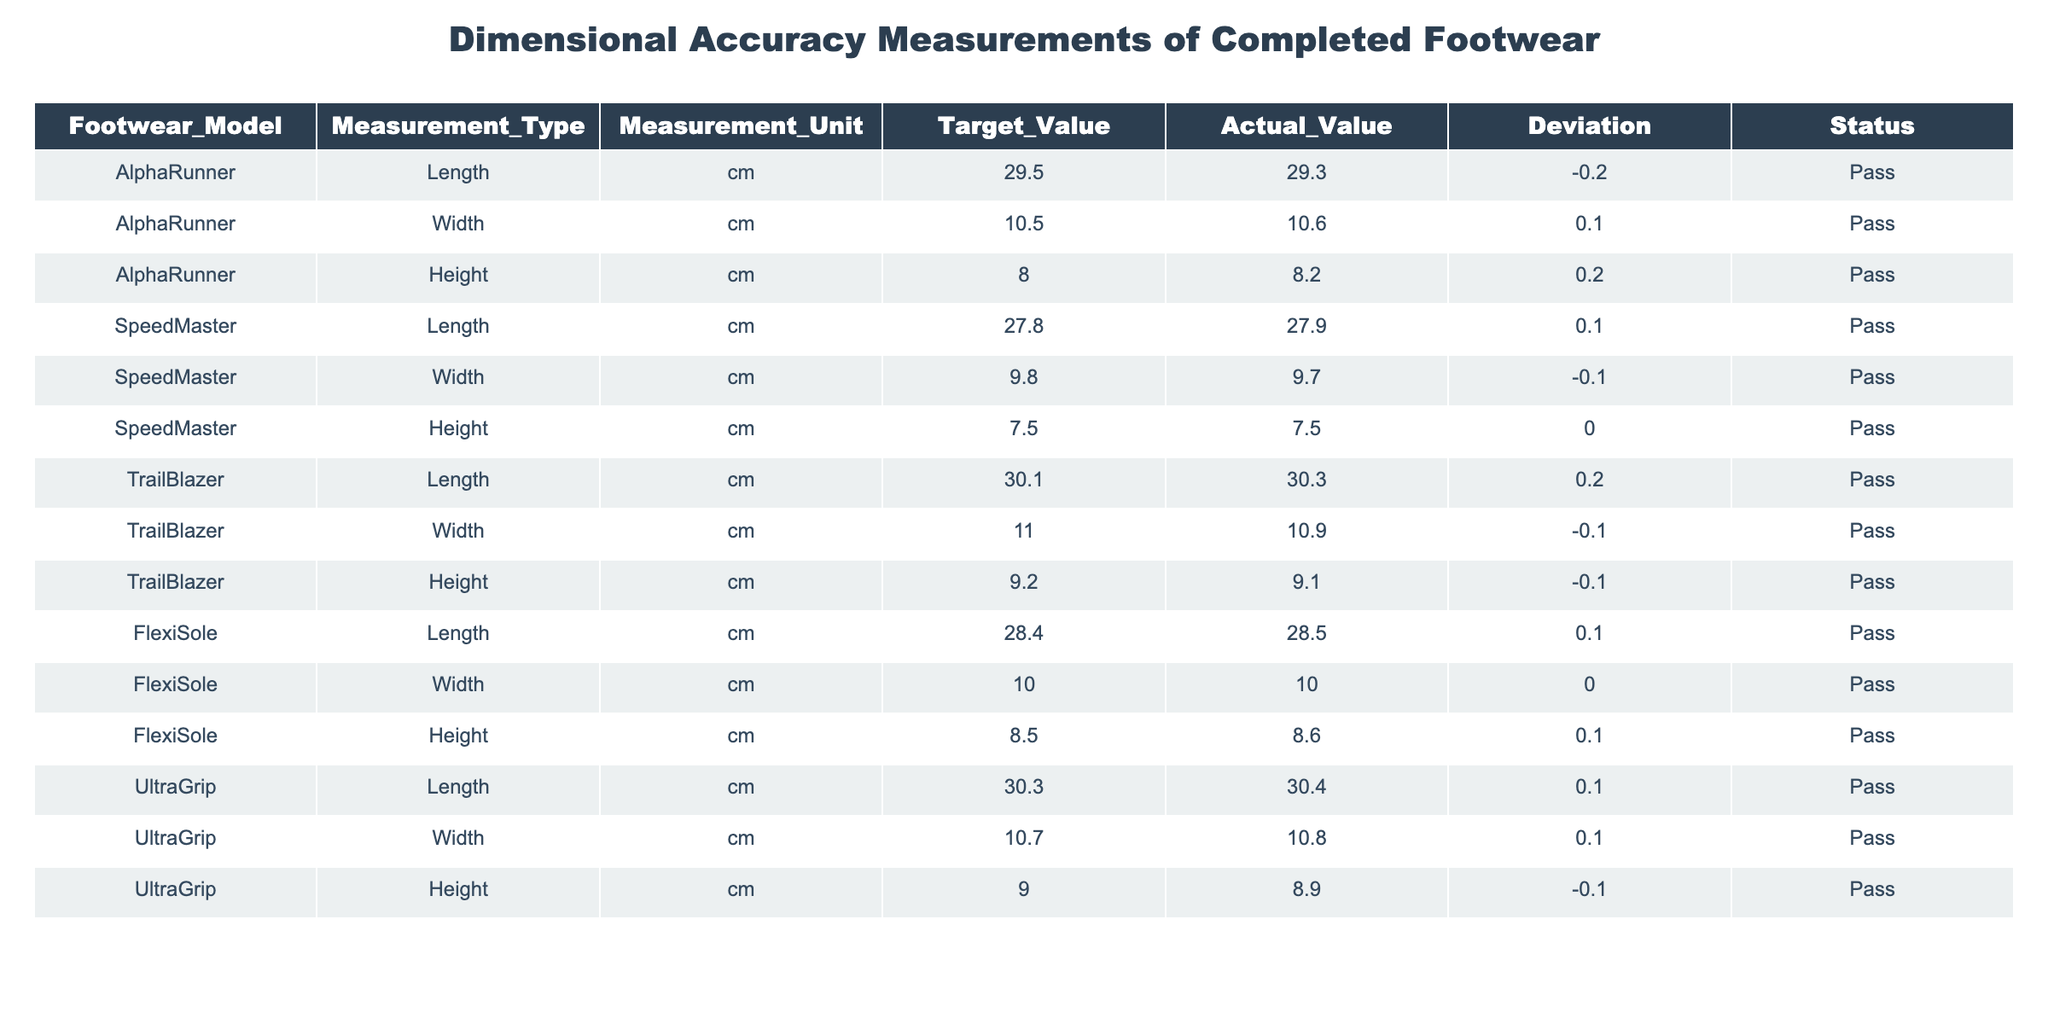What is the actual length measurement of the AlphaRunner model? Referring to the table, the actual length measurement for the AlphaRunner model is listed in the "Actual_Value" column under "Length." The value is 29.3 cm.
Answer: 29.3 cm What is the deviation value for the Width measurement of the UltraGrip model? The table indicates the deviation for the Width measurement of UltraGrip under the "Deviation" column. It shows a value of +0.1 cm.
Answer: +0.1 cm Is the Height measurement for the FlexiSole model within the target specifications? To determine this, we compare the actual Height (8.6 cm) with the target Height (8.5 cm). The current measurement exceeds the target by +0.1 cm, meaning it is slightly above the specification but still passes the quality check.
Answer: Yes What is the average Length measurement for all footwear models? The Length measurements from the table are 29.5, 27.8, 30.1, 28.4, and 30.3 cm. The sum of these values is 146.1 cm, and there are 5 models. Therefore, the average is 146.1 cm divided by 5, which equals 29.22 cm.
Answer: 29.22 cm Did any model exceed the height target, and if so, which one? By examining the Height measurements: AlphaRunner (8.2 cm), UltraGrip (8.9 cm), and FlexiSole (8.6 cm) all exceed their target heights, which are 8.0 cm, and hence they exceed expectations. Therefore, AlphaRunner and FlexiSole both exceeded the target.
Answer: Yes, AlphaRunner and FlexiSole What is the total deviation for all Width measurements in the table? The Width deviations are: +0.1 (AlphaRunner), -0.1 (SpeedMaster), -0.1 (TrailBlazer), 0.0 (FlexiSole), and +0.1 (UltraGrip). So, the total deviation is calculated as (+0.1) + (-0.1) + (-0.1) + (0.0) + (+0.1) = -0.1 cm.
Answer: -0.1 cm Which footwear model has the largest positive deviation in measurements? From the table, we can see that AlphaRunner's Height has a deviation of +0.2 cm. Comparing all positive deviations, no greater value is observed, indicating AlphaRunner has the largest positive deviation.
Answer: AlphaRunner Are all models passing the dimensional accuracy checks? Checking the "Status" column for each model, they all show "Pass," confirming that there are no failures in the dimensional accuracy checks for any of the models.
Answer: Yes 